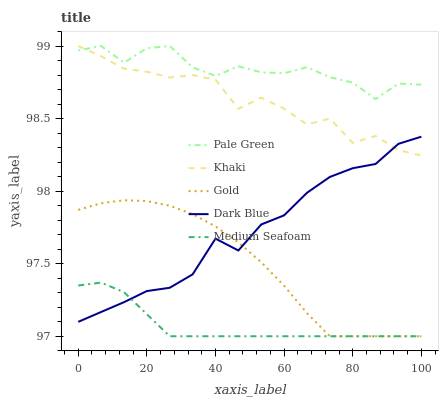Does Khaki have the minimum area under the curve?
Answer yes or no. No. Does Khaki have the maximum area under the curve?
Answer yes or no. No. Is Pale Green the smoothest?
Answer yes or no. No. Is Pale Green the roughest?
Answer yes or no. No. Does Khaki have the lowest value?
Answer yes or no. No. Does Gold have the highest value?
Answer yes or no. No. Is Dark Blue less than Pale Green?
Answer yes or no. Yes. Is Pale Green greater than Dark Blue?
Answer yes or no. Yes. Does Dark Blue intersect Pale Green?
Answer yes or no. No. 